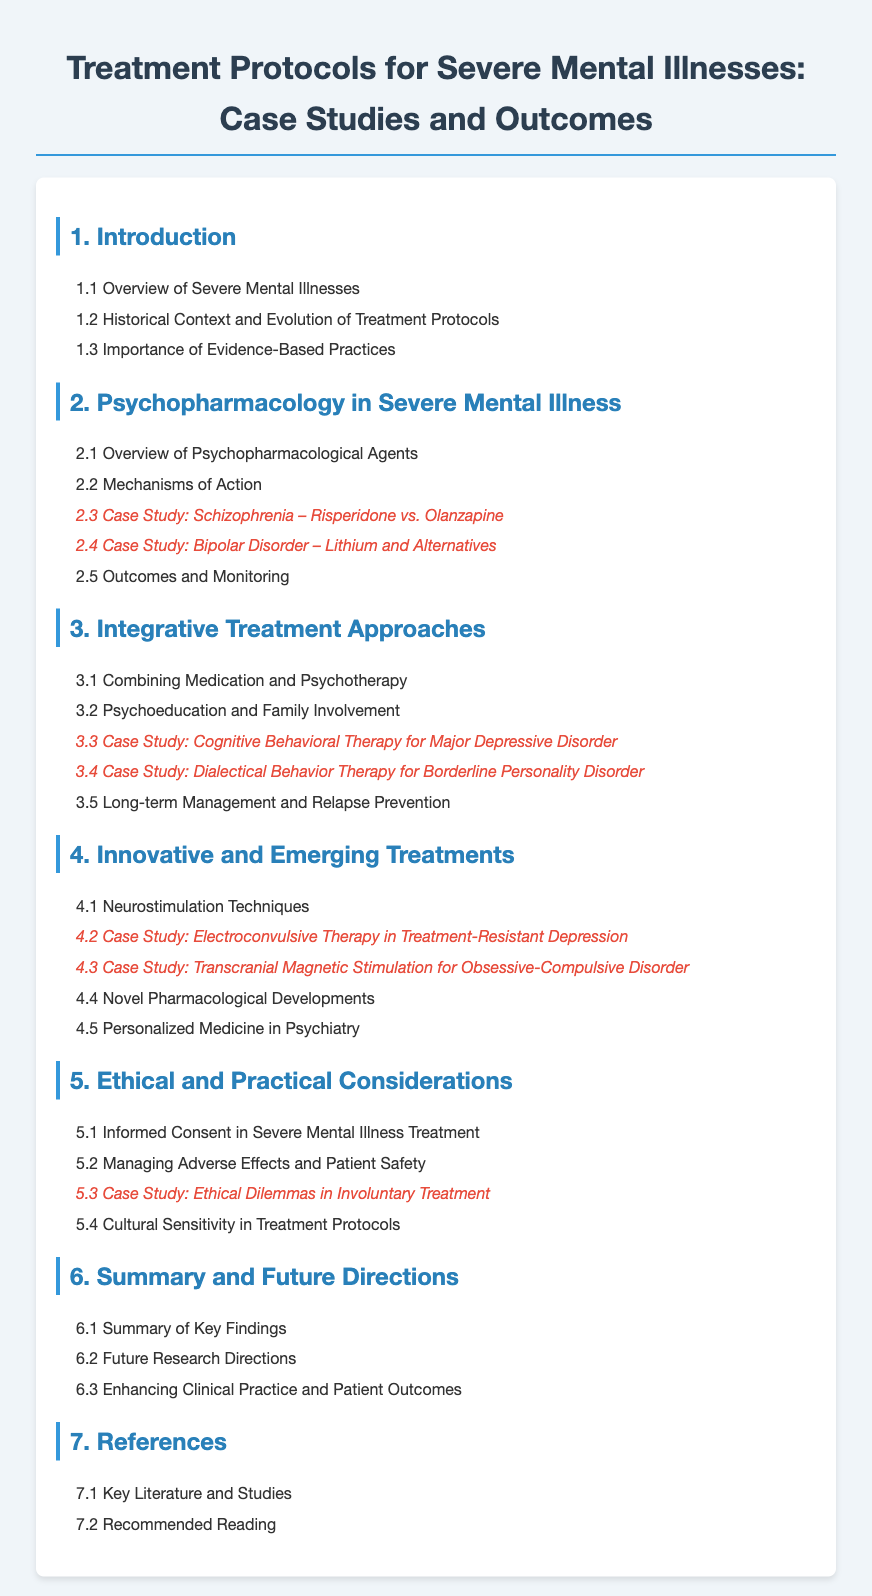What is the first section of the document? The first section is titled "Introduction."
Answer: Introduction Which case study addresses schizophrenia? The case study examining schizophrenia is titled "Case Study: Schizophrenia – Risperidone vs. Olanzapine."
Answer: Case Study: Schizophrenia – Risperidone vs. Olanzapine How many subsections are there under "Innovative and Emerging Treatments"? The section "Innovative and Emerging Treatments" includes five subsections.
Answer: 5 What is the focus of section 5? Section 5 focuses on "Ethical and Practical Considerations."
Answer: Ethical and Practical Considerations Which treatment is discussed in case study 4.2? Case study 4.2 discusses "Electroconvulsive Therapy in Treatment-Resistant Depression."
Answer: Electroconvulsive Therapy in Treatment-Resistant Depression What do the key literature references fall under? The key literature references fall under the last section titled "References."
Answer: References How many case studies are included in the document? There are a total of five case studies listed in the table of contents.
Answer: 5 What does subsection 6.2 propose? Subsection 6.2 proposes "Future Research Directions."
Answer: Future Research Directions 